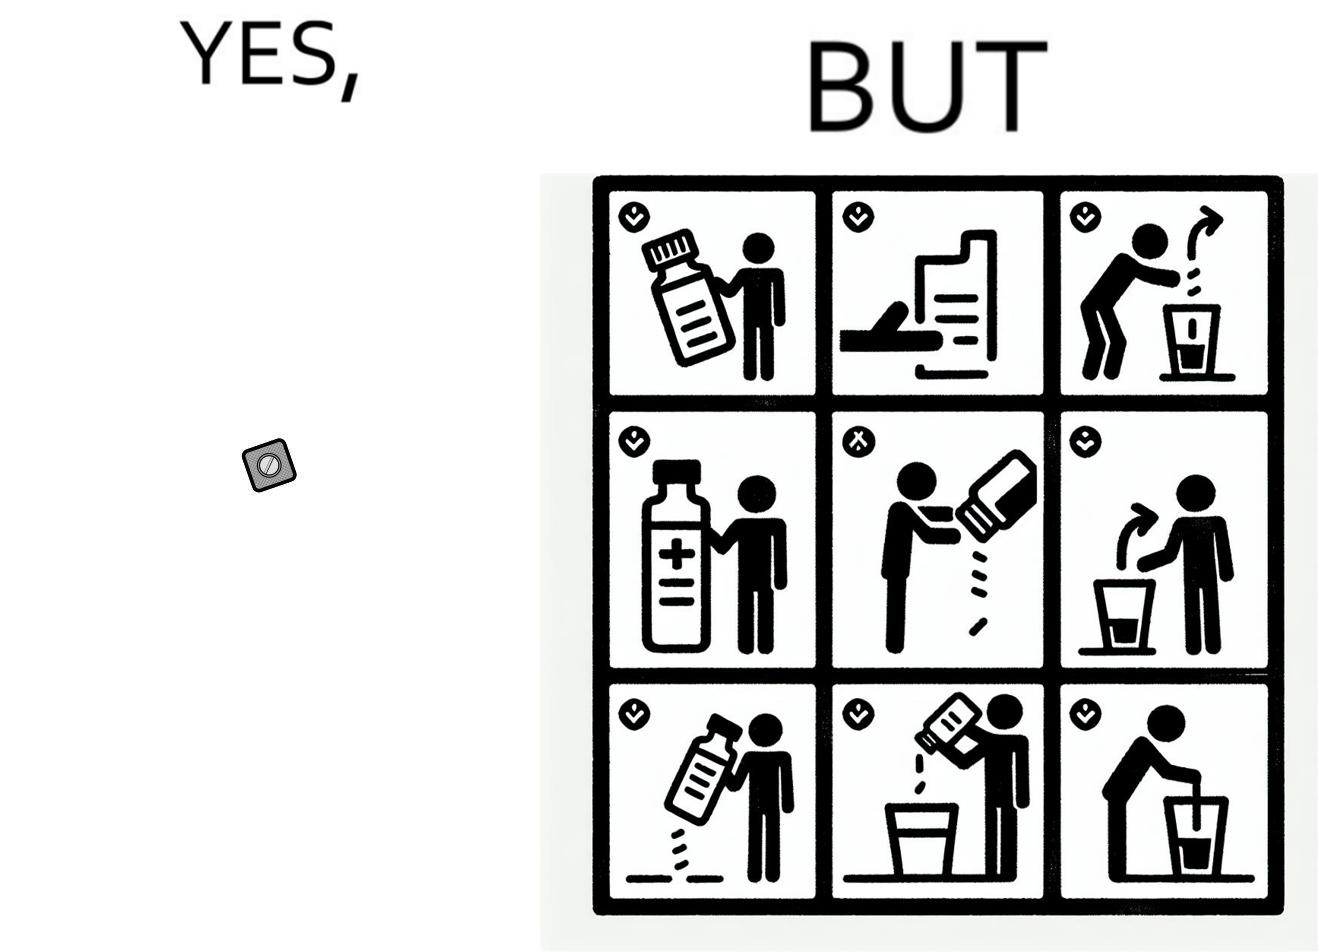Describe the contrast between the left and right parts of this image. In the left part of the image: a small tablet of a medicine In the right part of the image: a leaflet describing the instructions for a medicine 